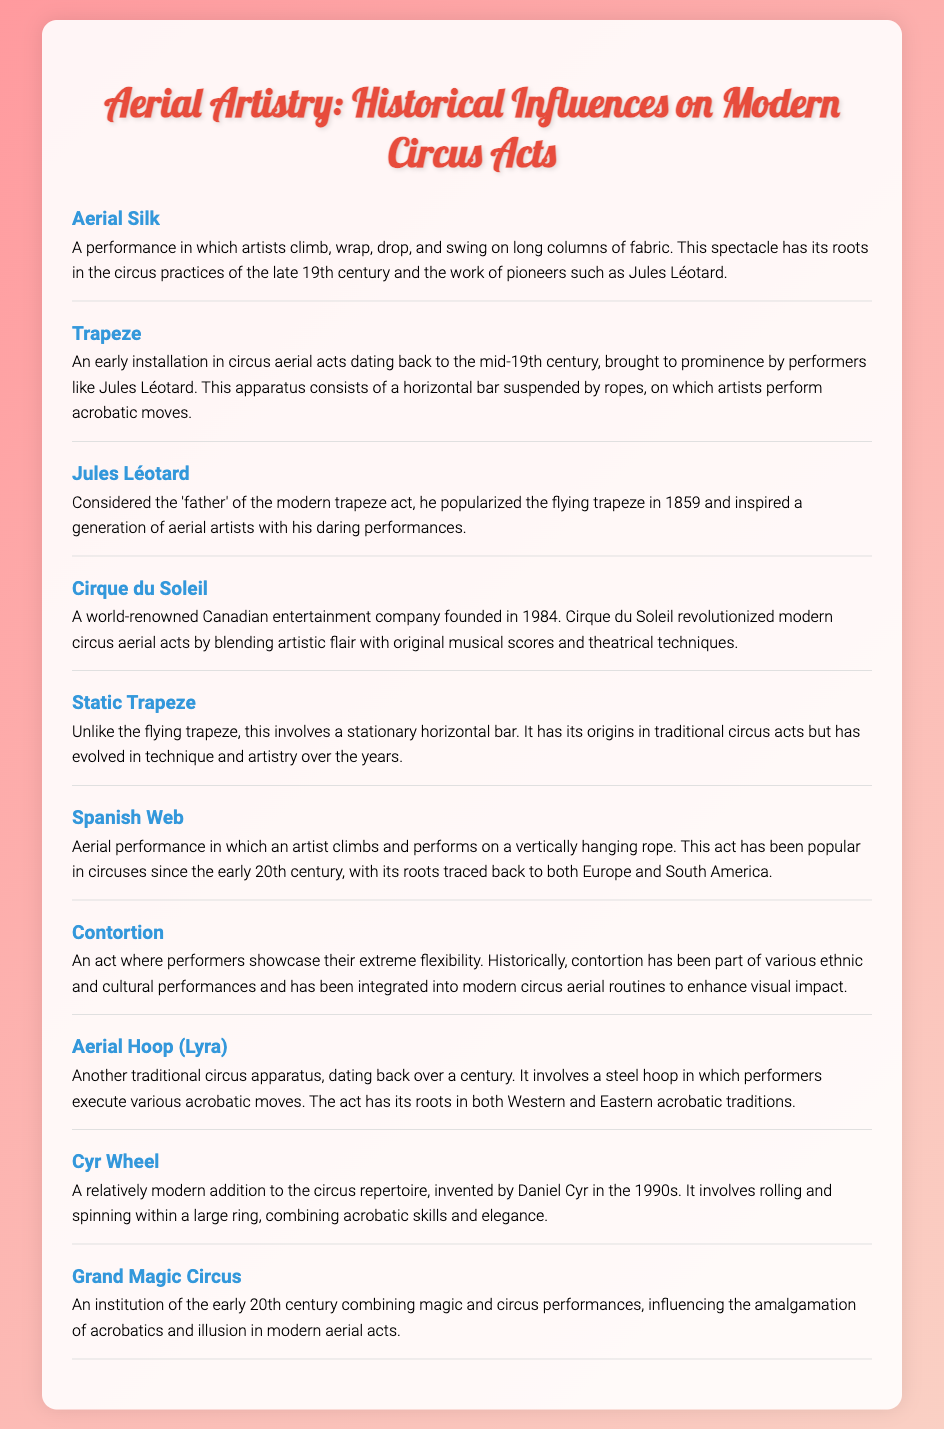What is Aerial Silk? Aerial Silk is defined as a performance in which artists climb, wrap, drop, and swing on long columns of fabric.
Answer: A performance in which artists climb, wrap, drop, and swing on long columns of fabric Who is considered the father of the modern trapeze act? The document identifies Jules Léotard as the person considered the father of the modern trapeze act.
Answer: Jules Léotard When was Cirque du Soleil founded? According to the document, Cirque du Soleil was founded in 1984.
Answer: 1984 What does the Static Trapeze consist of? The Static Trapeze is described as involving a stationary horizontal bar, which has its origins in traditional circus acts.
Answer: A stationary horizontal bar What type of performance is Spanish Web? Spanish Web is classified as an aerial performance in which an artist climbs and performs on a vertically hanging rope.
Answer: An aerial performance on a vertically hanging rope How did the Grand Magic Circus influence modern aerial acts? The Grand Magic Circus is noted for combining magic and circus performances, influencing the amalgamation of acrobatics and illusion in modern aerial acts.
Answer: By combining magic and circus performances What is the Cyr Wheel? The Cyr Wheel is defined as a relatively modern addition to the circus repertoire, invented by Daniel Cyr in the 1990s.
Answer: A relatively modern addition to the circus repertoire Describe the Aerial Hoop? The Aerial Hoop is described as a traditional circus apparatus that involves a steel hoop in which performers execute various acrobatic moves.
Answer: A traditional circus apparatus involving a steel hoop 